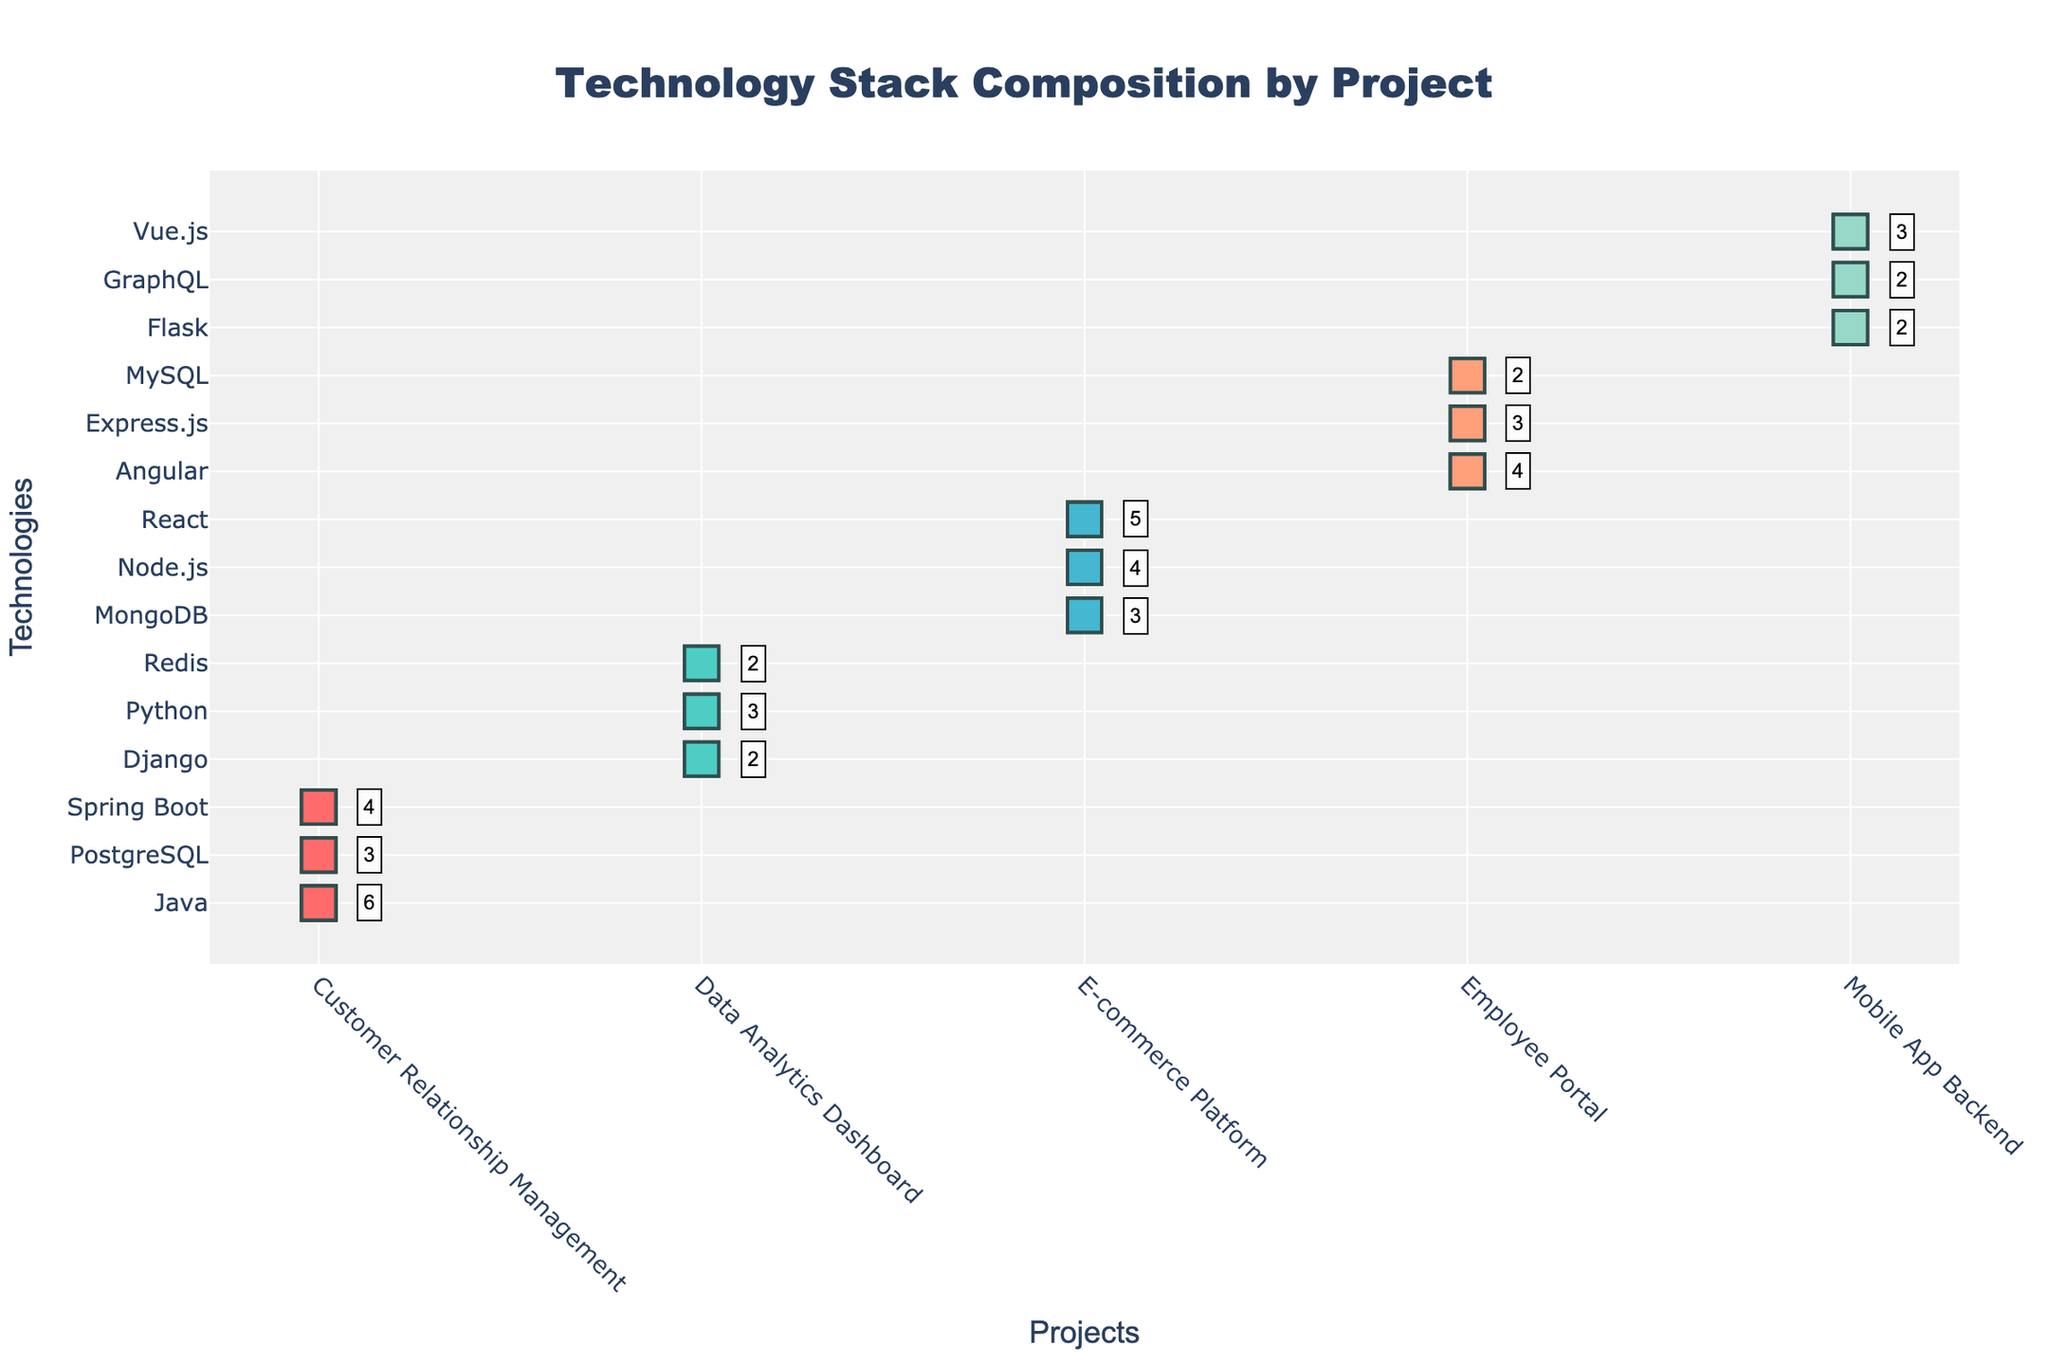what is the title of the figure? The title of the figure is usually displayed prominently at the top of the plot. Here, it reads "Technology Stack Composition by Project."
Answer: Technology Stack Composition by Project How many different projects are displayed? The different projects are labeled on the x-axis of the plot. Counting the unique labels, there are 5 projects.
Answer: 5 Which technology is used the most in the E-commerce Platform project? Observe the markers representing different technologies in the E-commerce Platform project. The technology with the most markers is React, with 5 markers.
Answer: React What is the combined count of technologies used in the Data Analytics Dashboard project? Sum the counts of different technologies in the Data Analytics Dashboard project. The counts are Python (3), Django (2), and Redis (2). Therefore, 3+2+2=7.
Answer: 7 How many technologies are used in the Customer Relationship Management project? Count the distinct technologies in the Customer Relationship Management project, which are Java, Spring Boot, and PostgreSQL. There are 3 technologies used.
Answer: 3 What is the sum of counts for Node.js and Angular across all projects? Sum the counts of Node.js (4 in E-commerce Platform) and Angular (4 in Employee Portal). Therefore, 4+4=8.
Answer: 8 Which project uses the fewest different technologies? Count the distinct technologies used in each project and find the project with the lowest count: E-commerce Platform (3), Customer Relationship Management (3), Employee Portal (3), Data Analytics Dashboard (3), Mobile App Backend (3). Therefore, all projects use the same number of different technologies
Answer: All Projects Compare the usage of MongoDB and MySQL across all projects. Which one is used more? Count the total instances of MongoDB (3 in E-commerce Platform) and MySQL (2 in Employee Portal). MongoDB is used more with 3 instances.
Answer: MongoDB Which technology has the highest count in the overall figure? Look at the counts of technologies across all projects. Java has the highest count with 6 markers.
Answer: Java Which project predominantly uses backend frameworks? Identify the projects and the primary nature (backend framework) of technologies they use. Both E-commerce Platform (Node.js, MongoDB) and Mobile App Backend (Django, Flask) predominantly use backend frameworks, but count the specific backend frameworks.
Answer: E-commerce Platform 